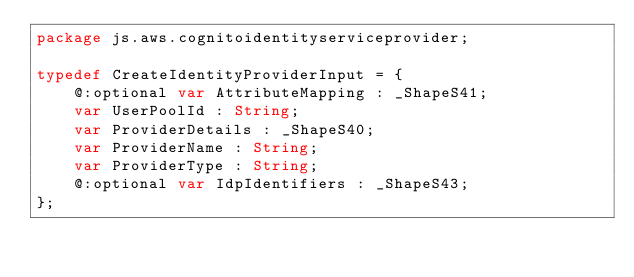<code> <loc_0><loc_0><loc_500><loc_500><_Haxe_>package js.aws.cognitoidentityserviceprovider;

typedef CreateIdentityProviderInput = {
    @:optional var AttributeMapping : _ShapeS41;
    var UserPoolId : String;
    var ProviderDetails : _ShapeS40;
    var ProviderName : String;
    var ProviderType : String;
    @:optional var IdpIdentifiers : _ShapeS43;
};
</code> 